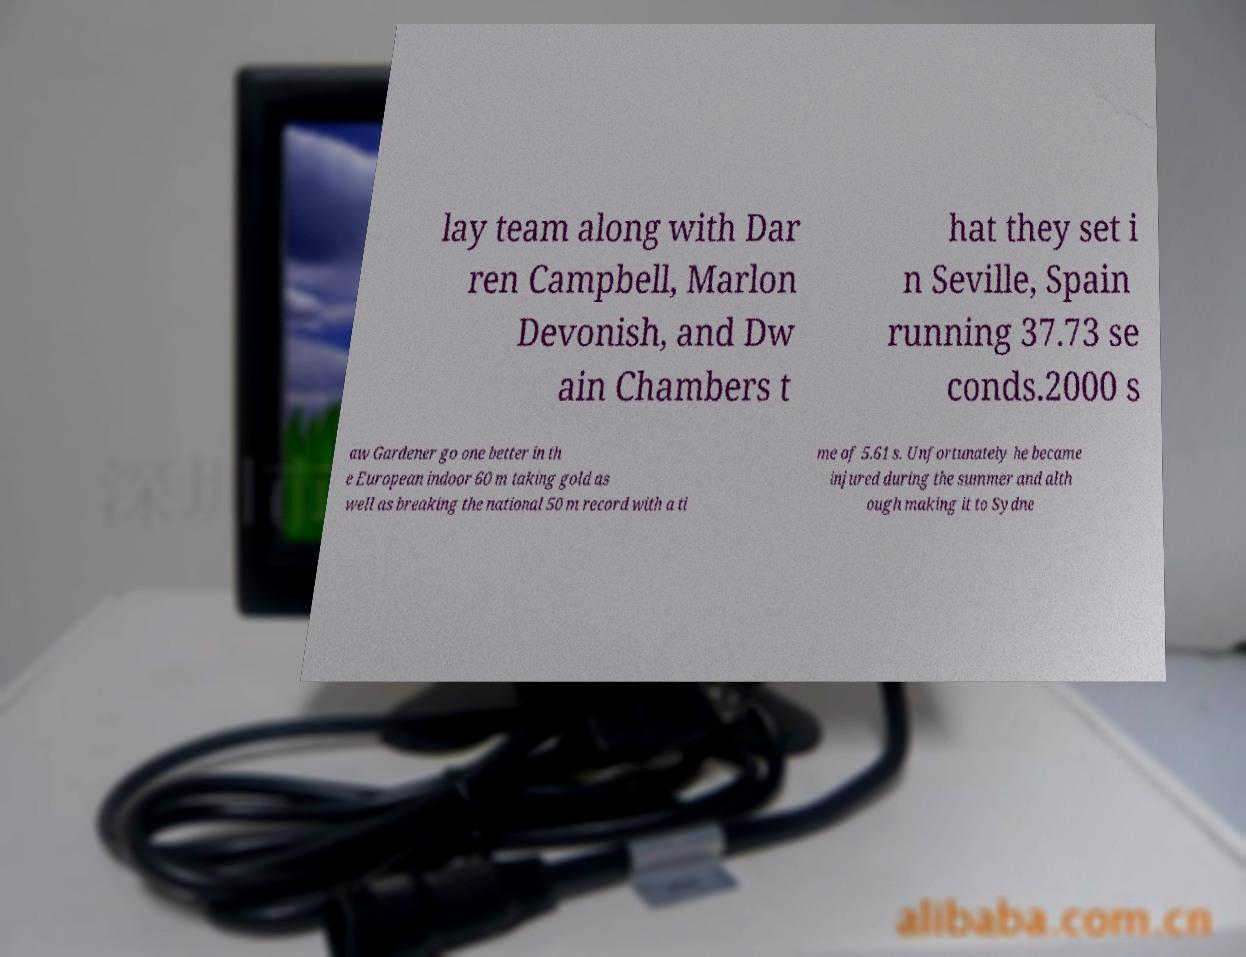Can you accurately transcribe the text from the provided image for me? lay team along with Dar ren Campbell, Marlon Devonish, and Dw ain Chambers t hat they set i n Seville, Spain running 37.73 se conds.2000 s aw Gardener go one better in th e European indoor 60 m taking gold as well as breaking the national 50 m record with a ti me of 5.61 s. Unfortunately he became injured during the summer and alth ough making it to Sydne 